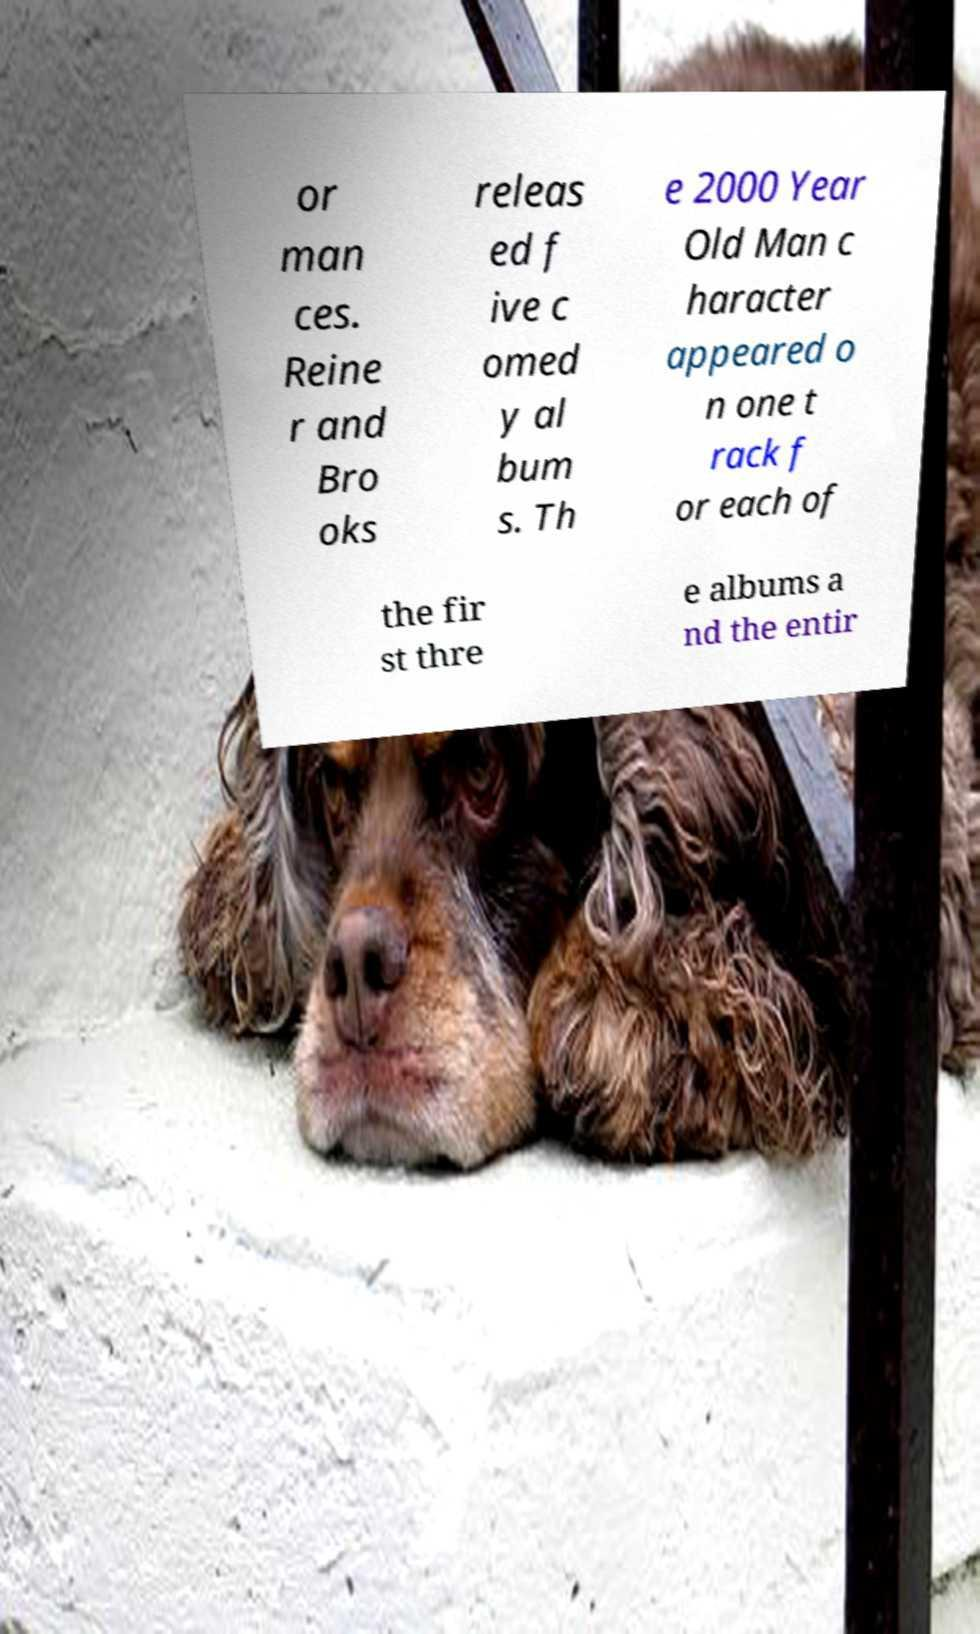Could you assist in decoding the text presented in this image and type it out clearly? or man ces. Reine r and Bro oks releas ed f ive c omed y al bum s. Th e 2000 Year Old Man c haracter appeared o n one t rack f or each of the fir st thre e albums a nd the entir 